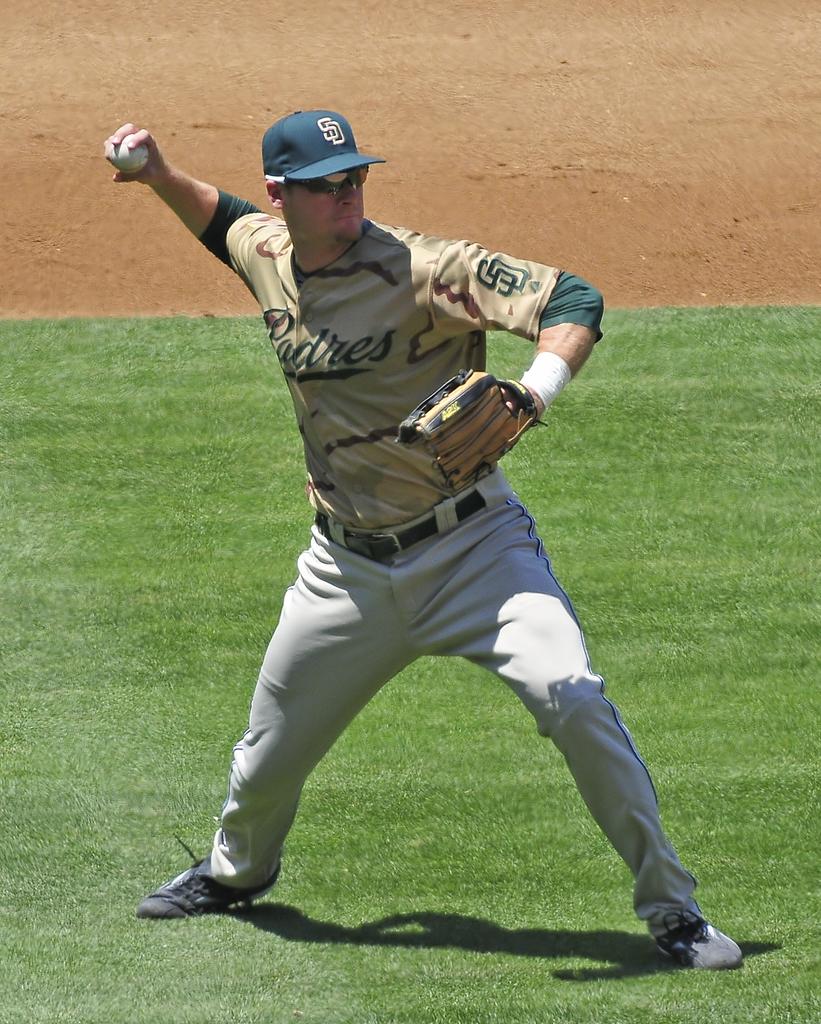What letter is on his hat?
Your answer should be compact. Sd. 